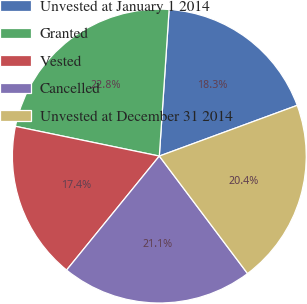<chart> <loc_0><loc_0><loc_500><loc_500><pie_chart><fcel>Unvested at January 1 2014<fcel>Granted<fcel>Vested<fcel>Cancelled<fcel>Unvested at December 31 2014<nl><fcel>18.33%<fcel>22.82%<fcel>17.38%<fcel>21.12%<fcel>20.36%<nl></chart> 